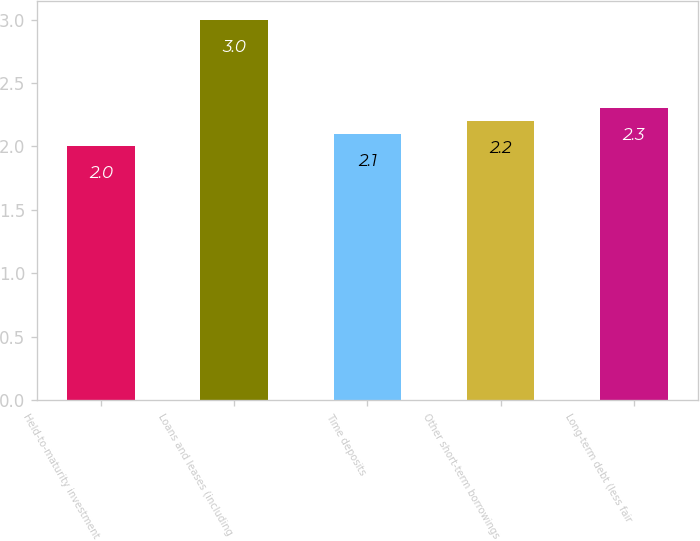<chart> <loc_0><loc_0><loc_500><loc_500><bar_chart><fcel>Held-to-maturity investment<fcel>Loans and leases (including<fcel>Time deposits<fcel>Other short-term borrowings<fcel>Long-term debt (less fair<nl><fcel>2<fcel>3<fcel>2.1<fcel>2.2<fcel>2.3<nl></chart> 